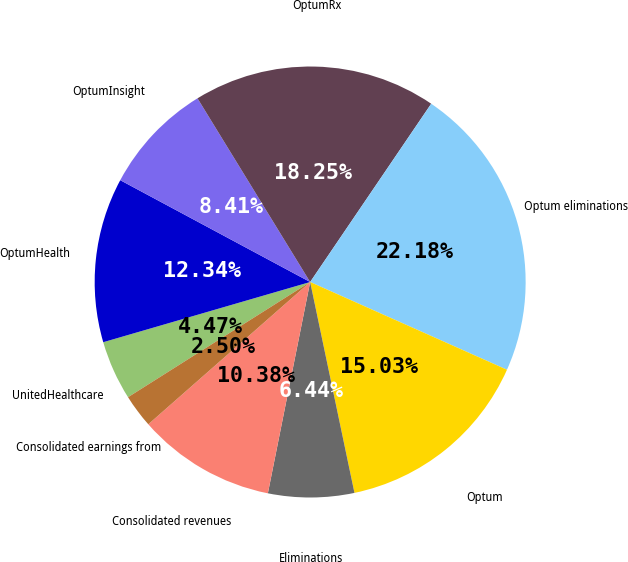Convert chart to OTSL. <chart><loc_0><loc_0><loc_500><loc_500><pie_chart><fcel>UnitedHealthcare<fcel>OptumHealth<fcel>OptumInsight<fcel>OptumRx<fcel>Optum eliminations<fcel>Optum<fcel>Eliminations<fcel>Consolidated revenues<fcel>Consolidated earnings from<nl><fcel>4.47%<fcel>12.34%<fcel>8.41%<fcel>18.25%<fcel>22.18%<fcel>15.03%<fcel>6.44%<fcel>10.38%<fcel>2.5%<nl></chart> 